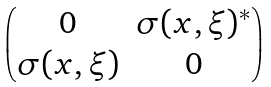Convert formula to latex. <formula><loc_0><loc_0><loc_500><loc_500>\begin{pmatrix} 0 & \sigma ( x , \xi ) ^ { * } \\ \sigma ( x , \xi ) & 0 \end{pmatrix}</formula> 